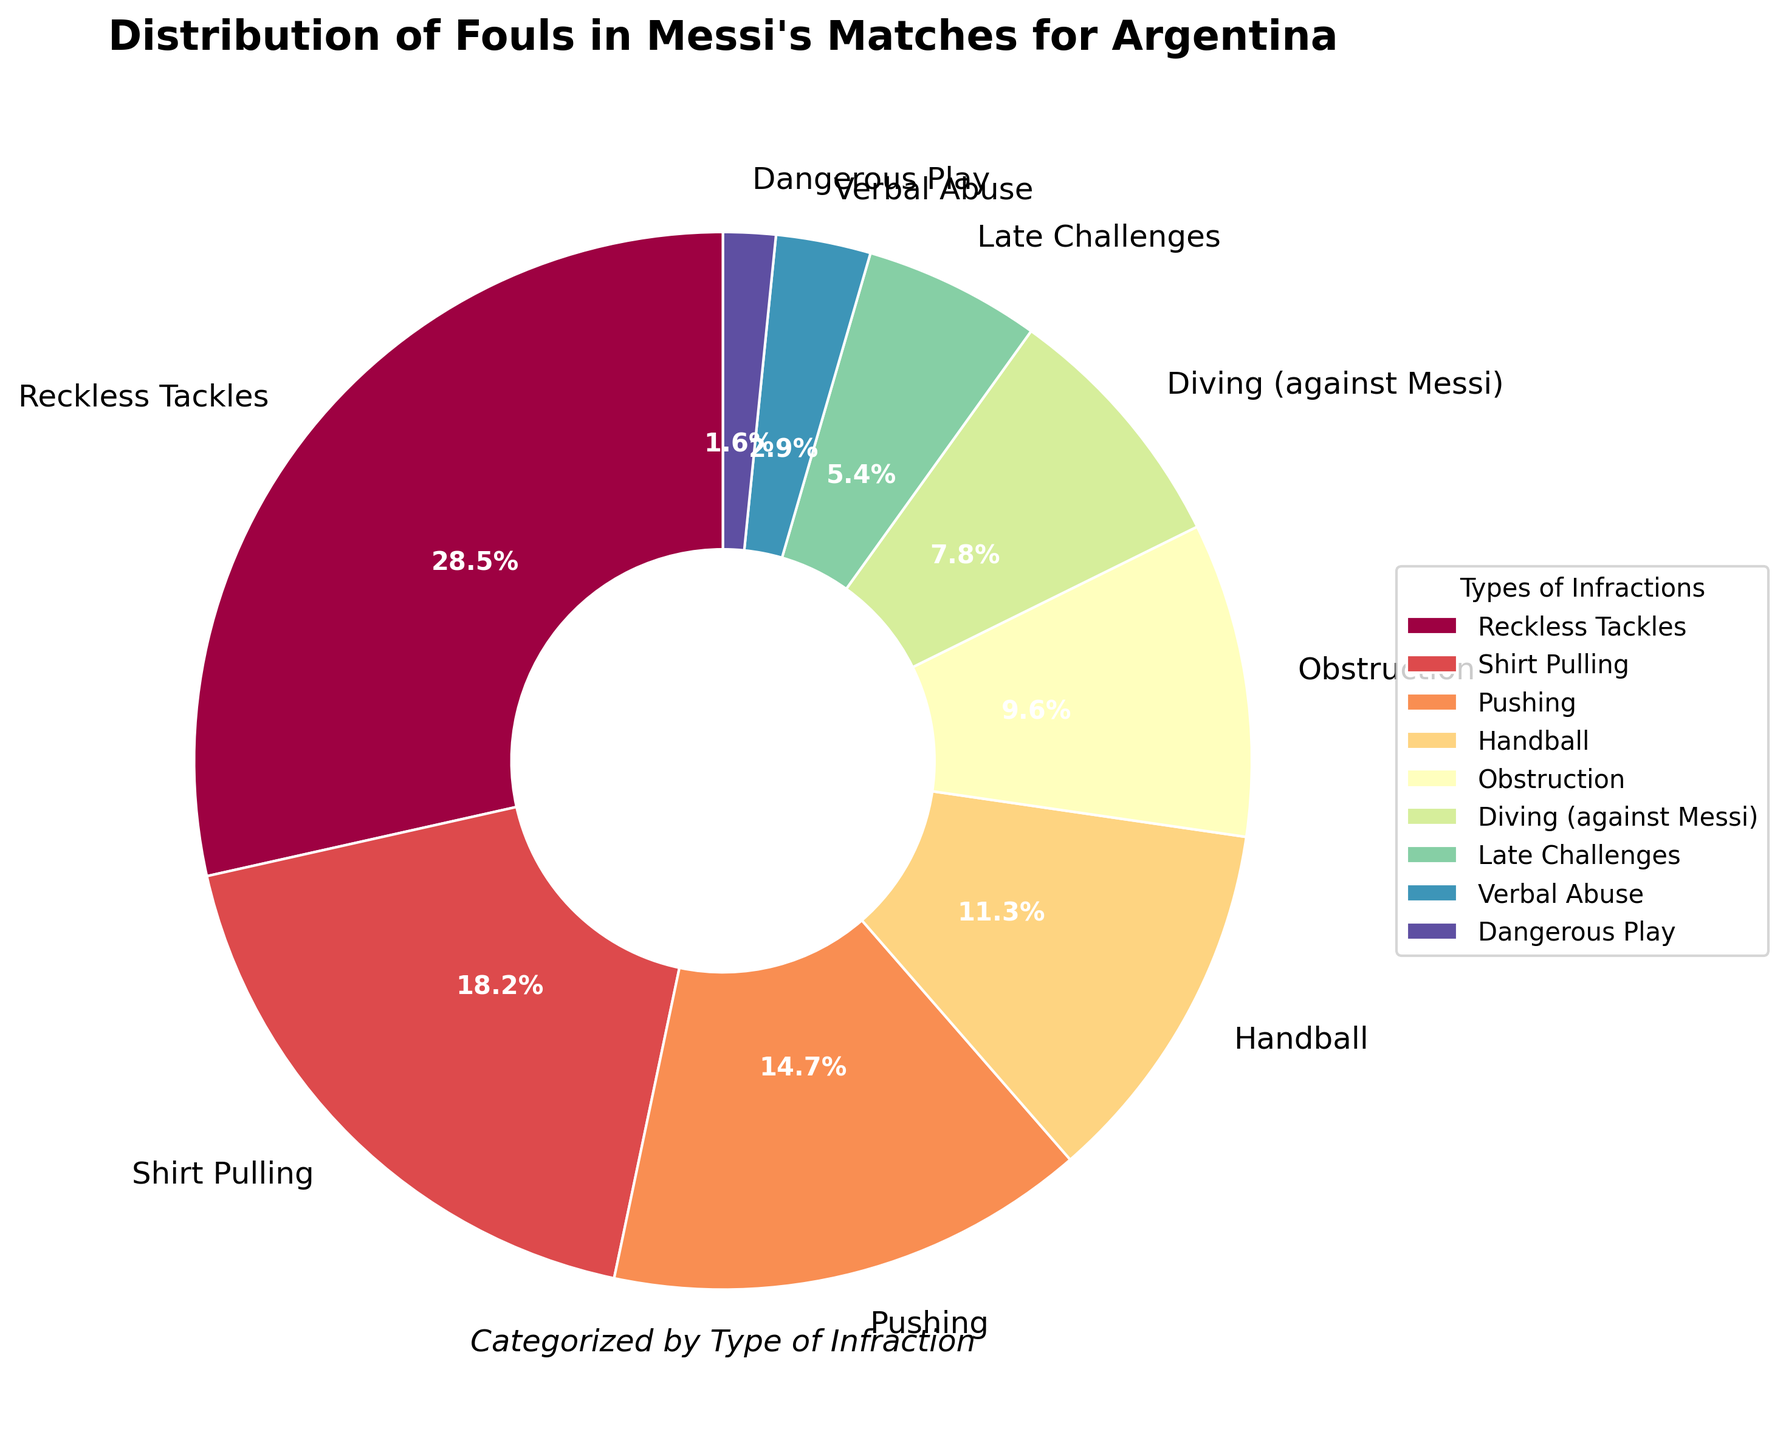what percentage of fouls is due to shirt pulling? Locate the section labeled "Shirt Pulling" in the pie chart. The percentage indicated is 18.2%.
Answer: 18.2% Which type of infraction has the lowest percentage? Scan all the labels and their corresponding percentages on the pie chart. The type with the lowest percentage is "Dangerous Play" at 1.6%.
Answer: Dangerous Play Which is more frequent: Reckless Tackles or Pushing? Compare the percentages for "Reckless Tackles" and "Pushing". Reckless Tackles are 28.5% while Pushing is 14.7%. So, Reckless Tackles are more frequent.
Answer: Reckless Tackles What is the combined percentage of Diving (against Messi) and Verbal Abuse? Add the percentages for "Diving (against Messi)" (7.8%) and "Verbal Abuse" (2.9%). The combined percentage is 7.8% + 2.9% = 10.7%.
Answer: 10.7% Are there more fouls from Obstruction or Pushing? Compare the percentages for "Obstruction" (9.6%) and "Pushing" (14.7%). Pushing has a higher percentage.
Answer: Pushing What is the total percentage of fouls related to Reckless Tackles, Shirt Pulling, and Pushing? Sum the percentages for "Reckless Tackles" (28.5%), "Shirt Pulling" (18.2%), and "Pushing" (14.7%). The total is 28.5% + 18.2% + 14.7% = 61.4%.
Answer: 61.4% How much more frequent are Handball fouls compared to Dangerous Play fouls? Subtract the percentage of "Dangerous Play" (1.6%) from "Handball" (11.3%). The difference is 11.3% - 1.6% = 9.7%.
Answer: 9.7% Which color section on the pie chart represents the largest type of infraction? Identify the color associated with the largest section of the pie chart which is labeled "Reckless Tackles" at 28.5%.
Answer: The color representing Reckless Tackles How does the frequency of Late Challenges compare to Diving (against Messi)? Compare the percentages of "Late Challenges" (5.4%) and "Diving (against Messi)" (7.8%). Diving (against Messi) has a higher percentage.
Answer: Diving (against Messi) What is the difference in percentage between Pushing and Obstruction? Subtract the percentage for "Obstruction" (9.6%) from "Pushing" (14.7%). The difference is 14.7% - 9.6% = 5.1%.
Answer: 5.1% 